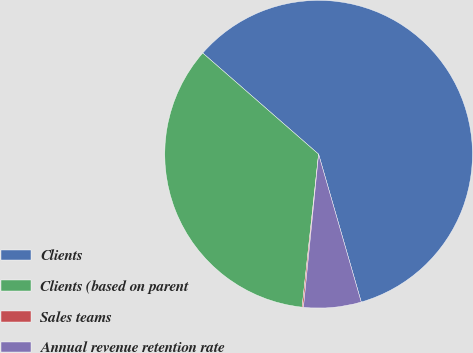Convert chart to OTSL. <chart><loc_0><loc_0><loc_500><loc_500><pie_chart><fcel>Clients<fcel>Clients (based on parent<fcel>Sales teams<fcel>Annual revenue retention rate<nl><fcel>59.11%<fcel>34.72%<fcel>0.14%<fcel>6.04%<nl></chart> 